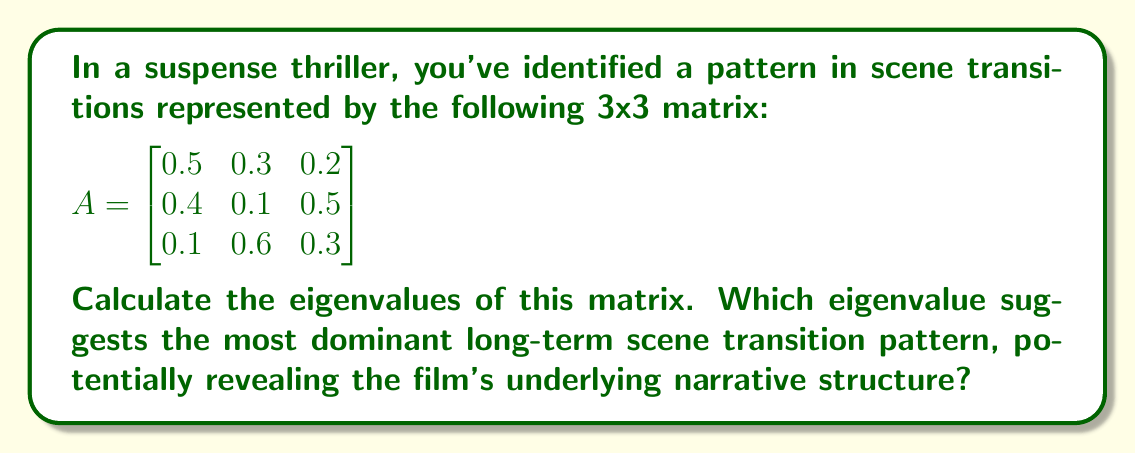Teach me how to tackle this problem. To find the eigenvalues of matrix A, we need to solve the characteristic equation:

1) First, we calculate $det(A - \lambda I)$, where $I$ is the 3x3 identity matrix:

   $$det\begin{pmatrix}
   0.5-\lambda & 0.3 & 0.2 \\
   0.4 & 0.1-\lambda & 0.5 \\
   0.1 & 0.6 & 0.3-\lambda
   \end{pmatrix} = 0$$

2) Expanding the determinant:
   
   $(0.5-\lambda)[(0.1-\lambda)(0.3-\lambda)-0.3] - 0.3[0.4(0.3-\lambda)-0.05] + 0.2[0.24-0.4(0.1-\lambda)] = 0$

3) Simplifying:

   $-\lambda^3 + 0.9\lambda^2 + 0.07\lambda - 0.006 = 0$

4) This cubic equation can be solved using various methods. Using a computer algebra system or numerical methods, we find the roots:

   $\lambda_1 \approx 1$
   $\lambda_2 \approx -0.05$
   $\lambda_3 \approx -0.05$

5) The eigenvalue with the largest magnitude is $\lambda_1 = 1$. This corresponds to the dominant eigenvector, which represents the most stable long-term scene transition pattern.

In the context of film analysis, this eigenvalue of 1 suggests a stable, recurring pattern in scene transitions that could reveal the underlying narrative structure of the film.
Answer: $\lambda_1 = 1$, $\lambda_2 = \lambda_3 \approx -0.05$; $\lambda_1 = 1$ is most dominant. 